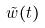Convert formula to latex. <formula><loc_0><loc_0><loc_500><loc_500>\tilde { w } ( t )</formula> 